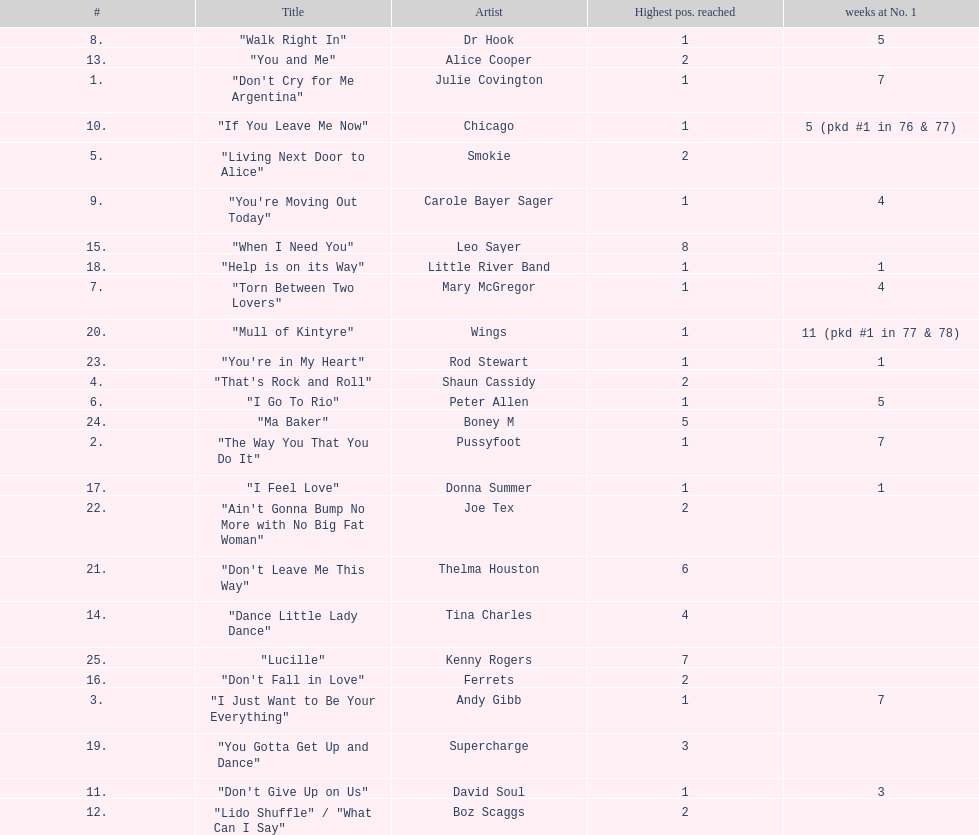How many songs in the table only reached position number 2? 6. 